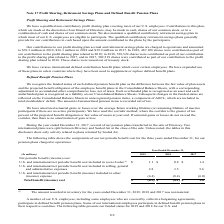According to Sealed Air Corporation's financial document, How was amortization of actuarial gains or losses over the average future working lifetime (or remaining lifetime of inactive participants if there are no active participants)? the corridor method, where the corridor is the greater of ten percent of the projected benefit obligation or fair value of assets at year end. If actuarial gains or losses do not exceed the corridor, then there is no amortization of gain or loss.. The document states: "if there are no active participants). We have used the corridor method, where the corridor is the greater of ten percent of the projected benefit obli..." Also, What does the table show? shows the components of our net periodic benefit cost for the three years ended December 31, for our pension plans charged to operations. The document states: "The following table shows the components of our net periodic benefit cost for the three years ended December 31, for our pension plans charged to oper..." Also, What occured during the year ended December 31, 2017? several of our pension plans transferred in the sale of Diversey. Two international plans were split between Diversey and Sealed Air at the close of the sale.. The document states: "During the year ended December 31, 2017, several of our pension plans transferred in the sale of Diversey. Two international plans were split between ..." Also, can you calculate: What is the average annual Total benefit (income) cost? To answer this question, I need to perform calculations using the financial data. The calculation is: (-0.5+-4.1+1)/3, which equals -1.2 (in millions). This is based on the information: ".4) (6.0) Total benefit (income) cost $ (0.5 ) $ (4.1 ) $ 1.0 .4) (6.0) Total benefit (income) cost $ (0.5 ) $ (4.1 ) $ 1.0 (4.4) (8.4) (6.0) Total benefit (income) cost $ (0.5 ) $ (4.1 ) $ 1.0..." The key data points involved are: 0.5, 4.1. Also, can you calculate: What is the percentage difference of the U.S. and international net periodic benefit cost included in cost of sales for year 2017 to year 2019? To answer this question, I need to perform calculations using the financial data. The calculation is: (1.1-1.4)/1.4, which equals -21.43 (percentage). This is based on the information: "cost included in cost of sales (1) $ 1.1 $ 0.8 $ 1.4 odic benefit cost included in cost of sales (1) $ 1.1 $ 0.8 $ 1.4..." The key data points involved are: 1.1. Also, can you calculate: What is the U.S. and international net periodic benefit cost included in cost of sales expressed as a percentage of U.S. and international net periodic benefit cost included in selling, general and administrative expenses of 2019? Based on the calculation: 1.1/2.8, the result is 39.29 (percentage). This is based on the information: "d in selling, general and administrative expenses 2.8 3.5 5.6 odic benefit cost included in cost of sales (1) $ 1.1 $ 0.8 $ 1.4..." The key data points involved are: 1.1, 2.8. 